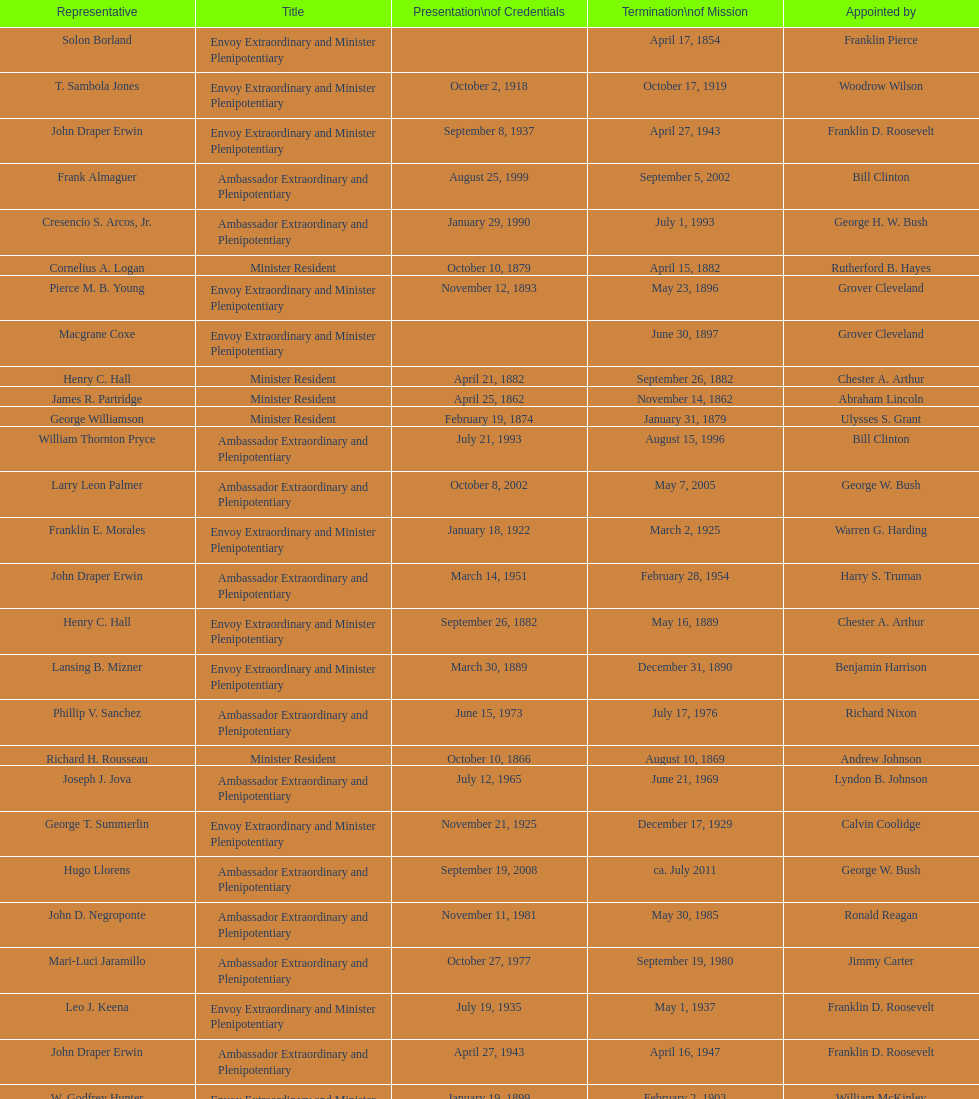How many representatives were appointed by theodore roosevelt? 4. I'm looking to parse the entire table for insights. Could you assist me with that? {'header': ['Representative', 'Title', 'Presentation\\nof Credentials', 'Termination\\nof Mission', 'Appointed by'], 'rows': [['Solon Borland', 'Envoy Extraordinary and Minister Plenipotentiary', '', 'April 17, 1854', 'Franklin Pierce'], ['T. Sambola Jones', 'Envoy Extraordinary and Minister Plenipotentiary', 'October 2, 1918', 'October 17, 1919', 'Woodrow Wilson'], ['John Draper Erwin', 'Envoy Extraordinary and Minister Plenipotentiary', 'September 8, 1937', 'April 27, 1943', 'Franklin D. Roosevelt'], ['Frank Almaguer', 'Ambassador Extraordinary and Plenipotentiary', 'August 25, 1999', 'September 5, 2002', 'Bill Clinton'], ['Cresencio S. Arcos, Jr.', 'Ambassador Extraordinary and Plenipotentiary', 'January 29, 1990', 'July 1, 1993', 'George H. W. Bush'], ['Cornelius A. Logan', 'Minister Resident', 'October 10, 1879', 'April 15, 1882', 'Rutherford B. Hayes'], ['Pierce M. B. Young', 'Envoy Extraordinary and Minister Plenipotentiary', 'November 12, 1893', 'May 23, 1896', 'Grover Cleveland'], ['Macgrane Coxe', 'Envoy Extraordinary and Minister Plenipotentiary', '', 'June 30, 1897', 'Grover Cleveland'], ['Henry C. Hall', 'Minister Resident', 'April 21, 1882', 'September 26, 1882', 'Chester A. Arthur'], ['James R. Partridge', 'Minister Resident', 'April 25, 1862', 'November 14, 1862', 'Abraham Lincoln'], ['George Williamson', 'Minister Resident', 'February 19, 1874', 'January 31, 1879', 'Ulysses S. Grant'], ['William Thornton Pryce', 'Ambassador Extraordinary and Plenipotentiary', 'July 21, 1993', 'August 15, 1996', 'Bill Clinton'], ['Larry Leon Palmer', 'Ambassador Extraordinary and Plenipotentiary', 'October 8, 2002', 'May 7, 2005', 'George W. Bush'], ['Franklin E. Morales', 'Envoy Extraordinary and Minister Plenipotentiary', 'January 18, 1922', 'March 2, 1925', 'Warren G. Harding'], ['John Draper Erwin', 'Ambassador Extraordinary and Plenipotentiary', 'March 14, 1951', 'February 28, 1954', 'Harry S. Truman'], ['Henry C. Hall', 'Envoy Extraordinary and Minister Plenipotentiary', 'September 26, 1882', 'May 16, 1889', 'Chester A. Arthur'], ['Lansing B. Mizner', 'Envoy Extraordinary and Minister Plenipotentiary', 'March 30, 1889', 'December 31, 1890', 'Benjamin Harrison'], ['Phillip V. Sanchez', 'Ambassador Extraordinary and Plenipotentiary', 'June 15, 1973', 'July 17, 1976', 'Richard Nixon'], ['Richard H. Rousseau', 'Minister Resident', 'October 10, 1866', 'August 10, 1869', 'Andrew Johnson'], ['Joseph J. Jova', 'Ambassador Extraordinary and Plenipotentiary', 'July 12, 1965', 'June 21, 1969', 'Lyndon B. Johnson'], ['George T. Summerlin', 'Envoy Extraordinary and Minister Plenipotentiary', 'November 21, 1925', 'December 17, 1929', 'Calvin Coolidge'], ['Hugo Llorens', 'Ambassador Extraordinary and Plenipotentiary', 'September 19, 2008', 'ca. July 2011', 'George W. Bush'], ['John D. Negroponte', 'Ambassador Extraordinary and Plenipotentiary', 'November 11, 1981', 'May 30, 1985', 'Ronald Reagan'], ['Mari-Luci Jaramillo', 'Ambassador Extraordinary and Plenipotentiary', 'October 27, 1977', 'September 19, 1980', 'Jimmy Carter'], ['Leo J. Keena', 'Envoy Extraordinary and Minister Plenipotentiary', 'July 19, 1935', 'May 1, 1937', 'Franklin D. Roosevelt'], ['John Draper Erwin', 'Ambassador Extraordinary and Plenipotentiary', 'April 27, 1943', 'April 16, 1947', 'Franklin D. Roosevelt'], ['W. Godfrey Hunter', 'Envoy Extraordinary and Minister Plenipotentiary', 'January 19, 1899', 'February 2, 1903', 'William McKinley'], ['Philip Marshall Brown', 'Envoy Extraordinary and Minister Plenipotentiary', 'February 21, 1909', 'February 26, 1910', 'Theodore Roosevelt'], ['Charles Dunning White', 'Envoy Extraordinary and Minister Plenipotentiary', 'September 9, 1911', 'November 4, 1913', 'William H. Taft'], ['Joseph W. J. Lee', 'Envoy Extraordinary and Minister Plenipotentiary', '', 'July 1, 1907', 'Theodore Roosevelt'], ['Leslie Combs', 'Envoy Extraordinary and Minister Plenipotentiary', 'May 22, 1903', 'February 27, 1907', 'Theodore Roosevelt'], ['Whiting Willauer', 'Ambassador Extraordinary and Plenipotentiary', 'March 5, 1954', 'March 24, 1958', 'Dwight D. Eisenhower'], ['Ralph E. Becker', 'Ambassador Extraordinary and Plenipotentiary', 'October 27, 1976', 'August 1, 1977', 'Gerald Ford'], ['Herbert S. Bursley', 'Ambassador Extraordinary and Plenipotentiary', 'May 15, 1948', 'December 12, 1950', 'Harry S. Truman'], ['Romualdo Pacheco', 'Envoy Extraordinary and Minister Plenipotentiary', 'April 17, 1891', 'June 12, 1893', 'Benjamin Harrison'], ['Charles A. Ford', 'Ambassador Extraordinary and Plenipotentiary', 'November 8, 2005', 'ca. April 2008', 'George W. Bush'], ['Charles R. Burrows', 'Ambassador Extraordinary and Plenipotentiary', 'November 3, 1960', 'June 28, 1965', 'Dwight D. Eisenhower'], ['Beverly L. Clarke', 'Minister Resident', 'August 10, 1858', 'March 17, 1860', 'James Buchanan'], ['Fenton R. McCreery', 'Envoy Extraordinary and Minister Plenipotentiary', 'March 10, 1910', 'July 2, 1911', 'William H. Taft'], ['H. Percival Dodge', 'Envoy Extraordinary and Minister Plenipotentiary', 'June 17, 1908', 'February 6, 1909', 'Theodore Roosevelt'], ['Everett Ellis Briggs', 'Ambassador Extraordinary and Plenipotentiary', 'November 4, 1986', 'June 15, 1989', 'Ronald Reagan'], ['Hewson A. Ryan', 'Ambassador Extraordinary and Plenipotentiary', 'November 5, 1969', 'May 30, 1973', 'Richard Nixon'], ['Paul C. Daniels', 'Ambassador Extraordinary and Plenipotentiary', 'June 23, 1947', 'October 30, 1947', 'Harry S. Truman'], ['Jack R. Binns', 'Ambassador Extraordinary and Plenipotentiary', 'October 10, 1980', 'October 31, 1981', 'Jimmy Carter'], ['Julius G. Lay', 'Envoy Extraordinary and Minister Plenipotentiary', 'May 31, 1930', 'March 17, 1935', 'Herbert Hoover'], ['Robert Newbegin', 'Ambassador Extraordinary and Plenipotentiary', 'April 30, 1958', 'August 3, 1960', 'Dwight D. Eisenhower'], ['John Ewing', 'Envoy Extraordinary and Minister Plenipotentiary', 'December 26, 1913', 'January 18, 1918', 'Woodrow Wilson'], ['Thomas H. Clay', 'Minister Resident', 'April 5, 1864', 'August 10, 1866', 'Abraham Lincoln'], ['Henry Baxter', 'Minister Resident', 'August 10, 1869', 'June 30, 1873', 'Ulysses S. Grant'], ['Lisa Kubiske', 'Ambassador Extraordinary and Plenipotentiary', 'July 26, 2011', 'Incumbent', 'Barack Obama'], ['John Arthur Ferch', 'Ambassador Extraordinary and Plenipotentiary', 'August 22, 1985', 'July 9, 1986', 'Ronald Reagan'], ['James F. Creagan', 'Ambassador Extraordinary and Plenipotentiary', 'August 29, 1996', 'July 20, 1999', 'Bill Clinton']]} 